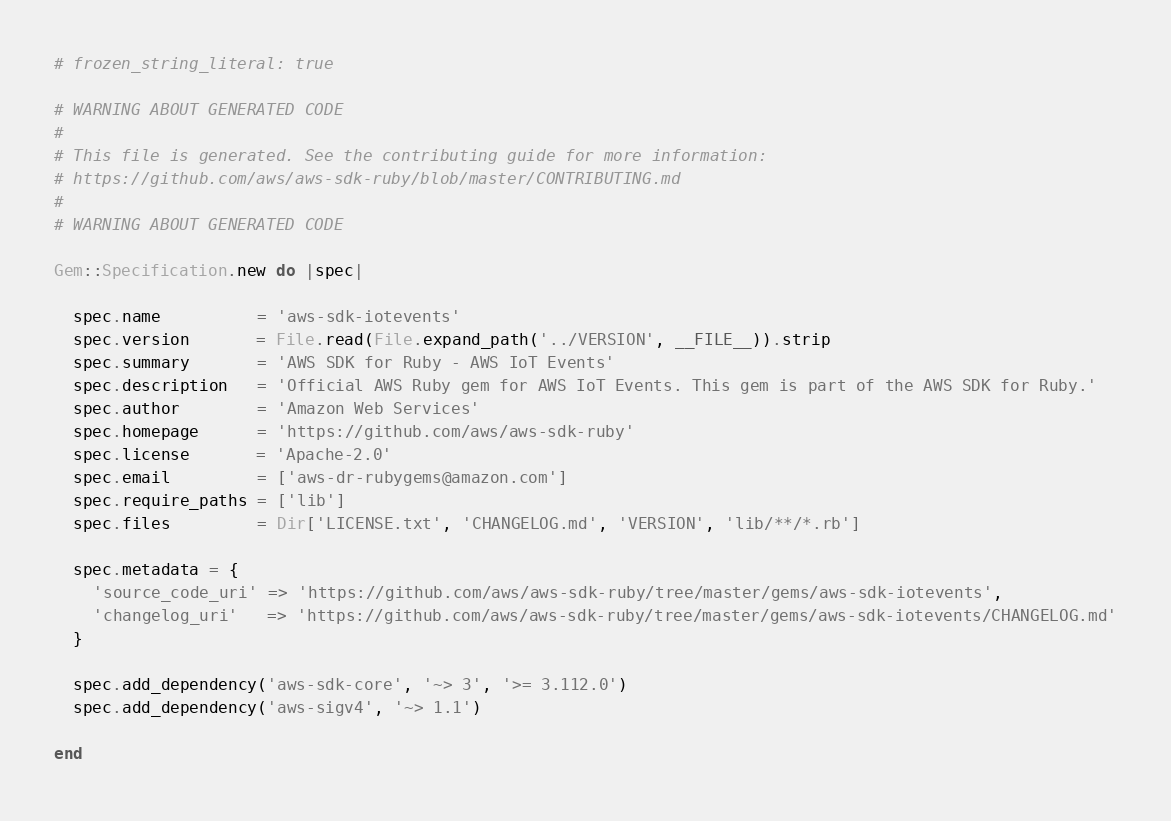<code> <loc_0><loc_0><loc_500><loc_500><_Ruby_># frozen_string_literal: true

# WARNING ABOUT GENERATED CODE
#
# This file is generated. See the contributing guide for more information:
# https://github.com/aws/aws-sdk-ruby/blob/master/CONTRIBUTING.md
#
# WARNING ABOUT GENERATED CODE

Gem::Specification.new do |spec|

  spec.name          = 'aws-sdk-iotevents'
  spec.version       = File.read(File.expand_path('../VERSION', __FILE__)).strip
  spec.summary       = 'AWS SDK for Ruby - AWS IoT Events'
  spec.description   = 'Official AWS Ruby gem for AWS IoT Events. This gem is part of the AWS SDK for Ruby.'
  spec.author        = 'Amazon Web Services'
  spec.homepage      = 'https://github.com/aws/aws-sdk-ruby'
  spec.license       = 'Apache-2.0'
  spec.email         = ['aws-dr-rubygems@amazon.com']
  spec.require_paths = ['lib']
  spec.files         = Dir['LICENSE.txt', 'CHANGELOG.md', 'VERSION', 'lib/**/*.rb']

  spec.metadata = {
    'source_code_uri' => 'https://github.com/aws/aws-sdk-ruby/tree/master/gems/aws-sdk-iotevents',
    'changelog_uri'   => 'https://github.com/aws/aws-sdk-ruby/tree/master/gems/aws-sdk-iotevents/CHANGELOG.md'
  }

  spec.add_dependency('aws-sdk-core', '~> 3', '>= 3.112.0')
  spec.add_dependency('aws-sigv4', '~> 1.1')

end
</code> 